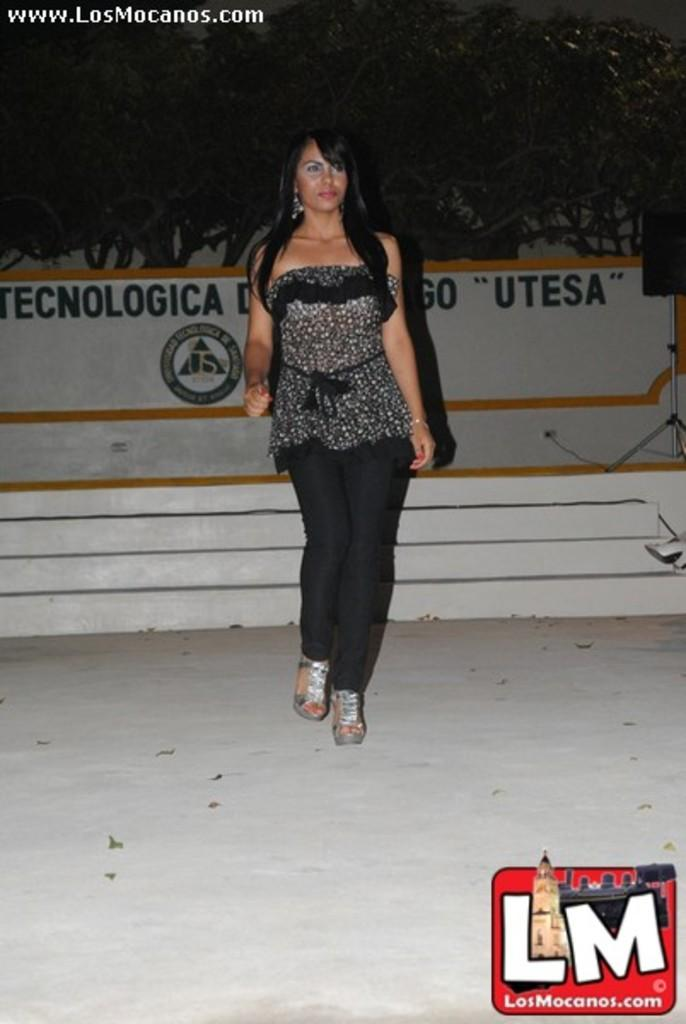What is the main subject of the image? There is a woman standing in the image. Where is the woman standing? The woman is standing on the ground. What can be seen in the background of the image? There is a staircase, a wall with text, a speaker on a stand, and a group of trees visible in the image. What type of leather is the woman wearing in the image? There is no leather visible in the image, as the woman is not wearing any clothing or accessories made of leather. 